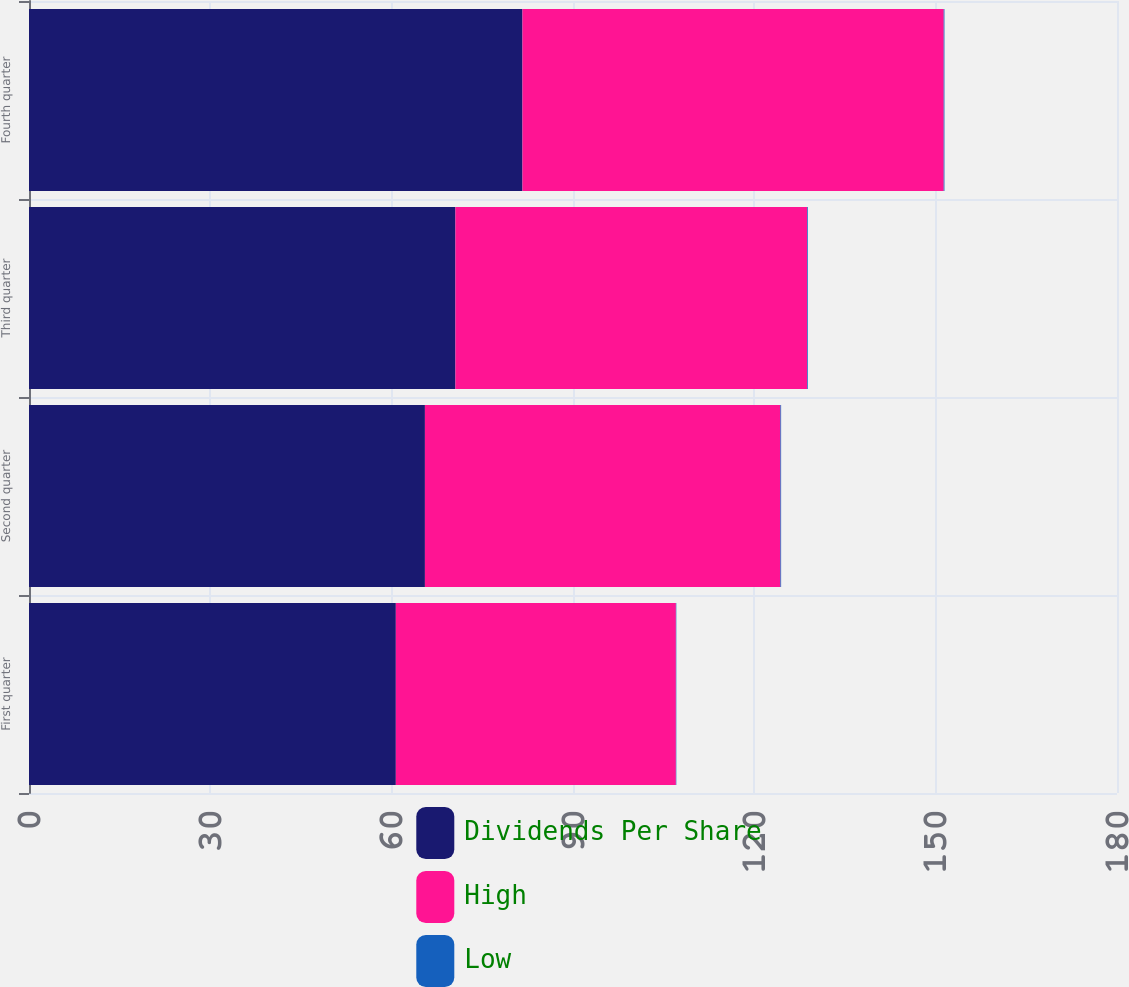Convert chart to OTSL. <chart><loc_0><loc_0><loc_500><loc_500><stacked_bar_chart><ecel><fcel>First quarter<fcel>Second quarter<fcel>Third quarter<fcel>Fourth quarter<nl><fcel>Dividends Per Share<fcel>60.69<fcel>65.5<fcel>70.55<fcel>81.64<nl><fcel>High<fcel>46.33<fcel>58.81<fcel>58.17<fcel>69.69<nl><fcel>Low<fcel>0.07<fcel>0.12<fcel>0.12<fcel>0.12<nl></chart> 